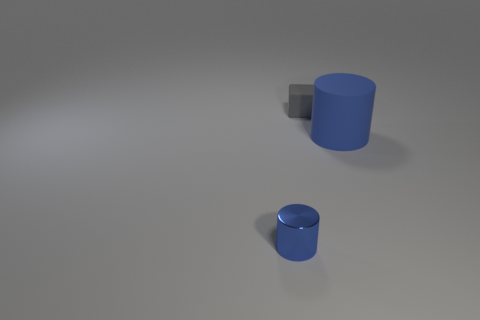There is a thing that is to the left of the blue matte thing and in front of the tiny gray thing; what is its color?
Provide a short and direct response. Blue. Is there anything else that is the same size as the matte cylinder?
Give a very brief answer. No. Are there more big things right of the metallic cylinder than rubber blocks in front of the matte cylinder?
Offer a very short reply. Yes. There is a blue object to the left of the gray thing; is its size the same as the small rubber cube?
Your answer should be very brief. Yes. There is a tiny thing that is in front of the blue object that is right of the cube; what number of cylinders are on the right side of it?
Give a very brief answer. 1. What is the size of the object that is right of the metallic object and in front of the gray cube?
Ensure brevity in your answer.  Large. How many other objects are there of the same shape as the tiny gray object?
Your answer should be very brief. 0. What number of big blue matte cylinders are in front of the tiny gray matte object?
Provide a succinct answer. 1. Are there fewer blue matte cylinders left of the large blue object than large rubber cylinders in front of the tiny gray block?
Make the answer very short. Yes. What shape is the blue thing behind the blue thing to the left of the cylinder right of the gray thing?
Provide a succinct answer. Cylinder. 